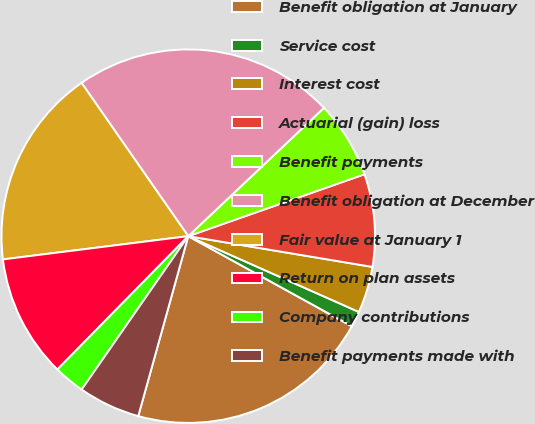Convert chart. <chart><loc_0><loc_0><loc_500><loc_500><pie_chart><fcel>Benefit obligation at January<fcel>Service cost<fcel>Interest cost<fcel>Actuarial (gain) loss<fcel>Benefit payments<fcel>Benefit obligation at December<fcel>Fair value at January 1<fcel>Return on plan assets<fcel>Company contributions<fcel>Benefit payments made with<nl><fcel>21.3%<fcel>1.36%<fcel>4.02%<fcel>8.01%<fcel>6.68%<fcel>22.62%<fcel>17.31%<fcel>10.66%<fcel>2.69%<fcel>5.35%<nl></chart> 